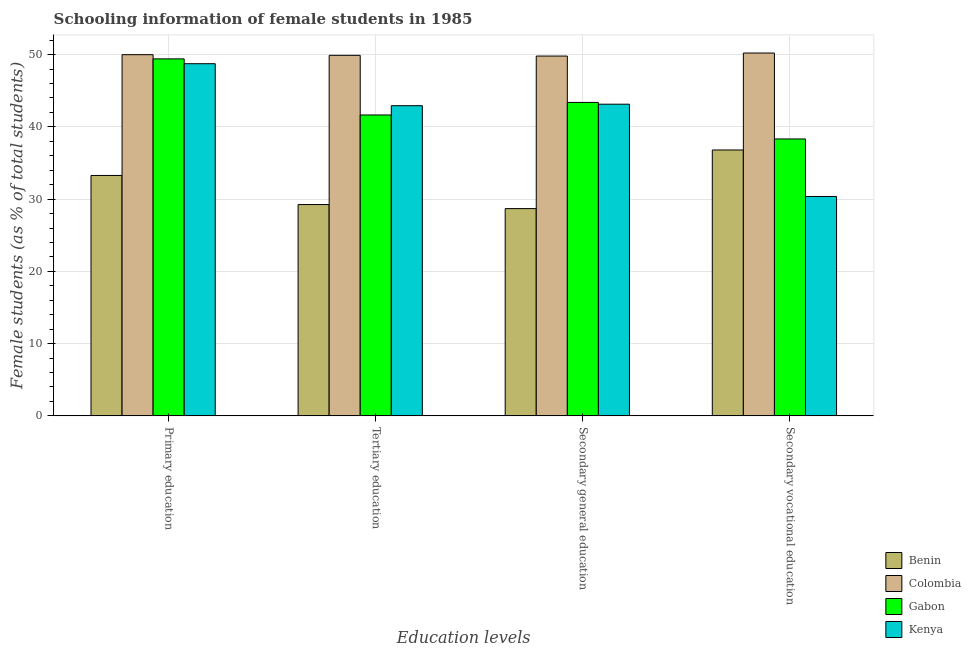How many different coloured bars are there?
Make the answer very short. 4. How many groups of bars are there?
Keep it short and to the point. 4. Are the number of bars per tick equal to the number of legend labels?
Give a very brief answer. Yes. How many bars are there on the 2nd tick from the left?
Keep it short and to the point. 4. What is the label of the 1st group of bars from the left?
Ensure brevity in your answer.  Primary education. What is the percentage of female students in primary education in Benin?
Your answer should be compact. 33.27. Across all countries, what is the maximum percentage of female students in secondary vocational education?
Provide a short and direct response. 50.22. Across all countries, what is the minimum percentage of female students in tertiary education?
Provide a succinct answer. 29.25. In which country was the percentage of female students in secondary education maximum?
Provide a short and direct response. Colombia. In which country was the percentage of female students in primary education minimum?
Provide a short and direct response. Benin. What is the total percentage of female students in primary education in the graph?
Provide a short and direct response. 181.41. What is the difference between the percentage of female students in secondary vocational education in Kenya and that in Benin?
Offer a very short reply. -6.44. What is the difference between the percentage of female students in secondary education in Gabon and the percentage of female students in tertiary education in Kenya?
Provide a short and direct response. 0.45. What is the average percentage of female students in secondary vocational education per country?
Your response must be concise. 38.93. What is the difference between the percentage of female students in tertiary education and percentage of female students in secondary vocational education in Kenya?
Provide a succinct answer. 12.56. In how many countries, is the percentage of female students in secondary education greater than 18 %?
Ensure brevity in your answer.  4. What is the ratio of the percentage of female students in primary education in Colombia to that in Gabon?
Your answer should be very brief. 1.01. Is the percentage of female students in secondary education in Gabon less than that in Colombia?
Your response must be concise. Yes. Is the difference between the percentage of female students in primary education in Kenya and Colombia greater than the difference between the percentage of female students in secondary education in Kenya and Colombia?
Your answer should be very brief. Yes. What is the difference between the highest and the second highest percentage of female students in primary education?
Make the answer very short. 0.58. What is the difference between the highest and the lowest percentage of female students in secondary education?
Make the answer very short. 21.11. In how many countries, is the percentage of female students in secondary education greater than the average percentage of female students in secondary education taken over all countries?
Your answer should be very brief. 3. Is the sum of the percentage of female students in tertiary education in Gabon and Kenya greater than the maximum percentage of female students in secondary education across all countries?
Your response must be concise. Yes. Is it the case that in every country, the sum of the percentage of female students in primary education and percentage of female students in secondary education is greater than the sum of percentage of female students in secondary vocational education and percentage of female students in tertiary education?
Provide a succinct answer. No. What does the 4th bar from the left in Secondary vocational education represents?
Make the answer very short. Kenya. What does the 1st bar from the right in Tertiary education represents?
Keep it short and to the point. Kenya. Is it the case that in every country, the sum of the percentage of female students in primary education and percentage of female students in tertiary education is greater than the percentage of female students in secondary education?
Your answer should be very brief. Yes. How many bars are there?
Offer a terse response. 16. Are all the bars in the graph horizontal?
Provide a short and direct response. No. How many countries are there in the graph?
Offer a terse response. 4. Does the graph contain grids?
Offer a terse response. Yes. How many legend labels are there?
Your response must be concise. 4. How are the legend labels stacked?
Provide a succinct answer. Vertical. What is the title of the graph?
Your response must be concise. Schooling information of female students in 1985. Does "Lao PDR" appear as one of the legend labels in the graph?
Your answer should be compact. No. What is the label or title of the X-axis?
Ensure brevity in your answer.  Education levels. What is the label or title of the Y-axis?
Provide a succinct answer. Female students (as % of total students). What is the Female students (as % of total students) of Benin in Primary education?
Your answer should be compact. 33.27. What is the Female students (as % of total students) of Colombia in Primary education?
Your answer should be compact. 49.99. What is the Female students (as % of total students) in Gabon in Primary education?
Provide a short and direct response. 49.41. What is the Female students (as % of total students) in Kenya in Primary education?
Your answer should be very brief. 48.74. What is the Female students (as % of total students) in Benin in Tertiary education?
Provide a succinct answer. 29.25. What is the Female students (as % of total students) of Colombia in Tertiary education?
Offer a terse response. 49.9. What is the Female students (as % of total students) in Gabon in Tertiary education?
Your answer should be compact. 41.64. What is the Female students (as % of total students) of Kenya in Tertiary education?
Your response must be concise. 42.93. What is the Female students (as % of total students) of Benin in Secondary general education?
Give a very brief answer. 28.69. What is the Female students (as % of total students) of Colombia in Secondary general education?
Offer a very short reply. 49.8. What is the Female students (as % of total students) of Gabon in Secondary general education?
Offer a very short reply. 43.38. What is the Female students (as % of total students) of Kenya in Secondary general education?
Offer a terse response. 43.14. What is the Female students (as % of total students) in Benin in Secondary vocational education?
Provide a short and direct response. 36.8. What is the Female students (as % of total students) in Colombia in Secondary vocational education?
Give a very brief answer. 50.22. What is the Female students (as % of total students) of Gabon in Secondary vocational education?
Give a very brief answer. 38.33. What is the Female students (as % of total students) in Kenya in Secondary vocational education?
Keep it short and to the point. 30.36. Across all Education levels, what is the maximum Female students (as % of total students) of Benin?
Your answer should be compact. 36.8. Across all Education levels, what is the maximum Female students (as % of total students) in Colombia?
Your answer should be very brief. 50.22. Across all Education levels, what is the maximum Female students (as % of total students) of Gabon?
Provide a short and direct response. 49.41. Across all Education levels, what is the maximum Female students (as % of total students) of Kenya?
Your answer should be compact. 48.74. Across all Education levels, what is the minimum Female students (as % of total students) in Benin?
Your answer should be compact. 28.69. Across all Education levels, what is the minimum Female students (as % of total students) of Colombia?
Your answer should be very brief. 49.8. Across all Education levels, what is the minimum Female students (as % of total students) of Gabon?
Your answer should be very brief. 38.33. Across all Education levels, what is the minimum Female students (as % of total students) of Kenya?
Make the answer very short. 30.36. What is the total Female students (as % of total students) of Benin in the graph?
Give a very brief answer. 128.01. What is the total Female students (as % of total students) of Colombia in the graph?
Offer a terse response. 199.91. What is the total Female students (as % of total students) of Gabon in the graph?
Your answer should be compact. 172.76. What is the total Female students (as % of total students) in Kenya in the graph?
Keep it short and to the point. 165.17. What is the difference between the Female students (as % of total students) in Benin in Primary education and that in Tertiary education?
Give a very brief answer. 4.03. What is the difference between the Female students (as % of total students) in Colombia in Primary education and that in Tertiary education?
Your response must be concise. 0.09. What is the difference between the Female students (as % of total students) of Gabon in Primary education and that in Tertiary education?
Offer a terse response. 7.76. What is the difference between the Female students (as % of total students) in Kenya in Primary education and that in Tertiary education?
Your response must be concise. 5.81. What is the difference between the Female students (as % of total students) in Benin in Primary education and that in Secondary general education?
Keep it short and to the point. 4.59. What is the difference between the Female students (as % of total students) in Colombia in Primary education and that in Secondary general education?
Offer a terse response. 0.19. What is the difference between the Female students (as % of total students) in Gabon in Primary education and that in Secondary general education?
Ensure brevity in your answer.  6.03. What is the difference between the Female students (as % of total students) in Kenya in Primary education and that in Secondary general education?
Your response must be concise. 5.6. What is the difference between the Female students (as % of total students) of Benin in Primary education and that in Secondary vocational education?
Offer a very short reply. -3.53. What is the difference between the Female students (as % of total students) of Colombia in Primary education and that in Secondary vocational education?
Give a very brief answer. -0.23. What is the difference between the Female students (as % of total students) of Gabon in Primary education and that in Secondary vocational education?
Your response must be concise. 11.08. What is the difference between the Female students (as % of total students) of Kenya in Primary education and that in Secondary vocational education?
Provide a succinct answer. 18.37. What is the difference between the Female students (as % of total students) in Benin in Tertiary education and that in Secondary general education?
Ensure brevity in your answer.  0.56. What is the difference between the Female students (as % of total students) of Colombia in Tertiary education and that in Secondary general education?
Provide a short and direct response. 0.1. What is the difference between the Female students (as % of total students) of Gabon in Tertiary education and that in Secondary general education?
Your response must be concise. -1.74. What is the difference between the Female students (as % of total students) in Kenya in Tertiary education and that in Secondary general education?
Ensure brevity in your answer.  -0.21. What is the difference between the Female students (as % of total students) of Benin in Tertiary education and that in Secondary vocational education?
Provide a succinct answer. -7.55. What is the difference between the Female students (as % of total students) of Colombia in Tertiary education and that in Secondary vocational education?
Provide a succinct answer. -0.32. What is the difference between the Female students (as % of total students) of Gabon in Tertiary education and that in Secondary vocational education?
Offer a terse response. 3.32. What is the difference between the Female students (as % of total students) of Kenya in Tertiary education and that in Secondary vocational education?
Your answer should be compact. 12.56. What is the difference between the Female students (as % of total students) of Benin in Secondary general education and that in Secondary vocational education?
Keep it short and to the point. -8.11. What is the difference between the Female students (as % of total students) of Colombia in Secondary general education and that in Secondary vocational education?
Give a very brief answer. -0.42. What is the difference between the Female students (as % of total students) in Gabon in Secondary general education and that in Secondary vocational education?
Give a very brief answer. 5.06. What is the difference between the Female students (as % of total students) of Kenya in Secondary general education and that in Secondary vocational education?
Ensure brevity in your answer.  12.77. What is the difference between the Female students (as % of total students) of Benin in Primary education and the Female students (as % of total students) of Colombia in Tertiary education?
Keep it short and to the point. -16.63. What is the difference between the Female students (as % of total students) in Benin in Primary education and the Female students (as % of total students) in Gabon in Tertiary education?
Your response must be concise. -8.37. What is the difference between the Female students (as % of total students) in Benin in Primary education and the Female students (as % of total students) in Kenya in Tertiary education?
Keep it short and to the point. -9.66. What is the difference between the Female students (as % of total students) in Colombia in Primary education and the Female students (as % of total students) in Gabon in Tertiary education?
Your answer should be compact. 8.35. What is the difference between the Female students (as % of total students) in Colombia in Primary education and the Female students (as % of total students) in Kenya in Tertiary education?
Provide a succinct answer. 7.06. What is the difference between the Female students (as % of total students) of Gabon in Primary education and the Female students (as % of total students) of Kenya in Tertiary education?
Give a very brief answer. 6.48. What is the difference between the Female students (as % of total students) in Benin in Primary education and the Female students (as % of total students) in Colombia in Secondary general education?
Your answer should be compact. -16.53. What is the difference between the Female students (as % of total students) in Benin in Primary education and the Female students (as % of total students) in Gabon in Secondary general education?
Keep it short and to the point. -10.11. What is the difference between the Female students (as % of total students) of Benin in Primary education and the Female students (as % of total students) of Kenya in Secondary general education?
Ensure brevity in your answer.  -9.86. What is the difference between the Female students (as % of total students) in Colombia in Primary education and the Female students (as % of total students) in Gabon in Secondary general education?
Provide a succinct answer. 6.61. What is the difference between the Female students (as % of total students) of Colombia in Primary education and the Female students (as % of total students) of Kenya in Secondary general education?
Offer a very short reply. 6.85. What is the difference between the Female students (as % of total students) in Gabon in Primary education and the Female students (as % of total students) in Kenya in Secondary general education?
Provide a succinct answer. 6.27. What is the difference between the Female students (as % of total students) of Benin in Primary education and the Female students (as % of total students) of Colombia in Secondary vocational education?
Make the answer very short. -16.95. What is the difference between the Female students (as % of total students) in Benin in Primary education and the Female students (as % of total students) in Gabon in Secondary vocational education?
Offer a very short reply. -5.05. What is the difference between the Female students (as % of total students) in Benin in Primary education and the Female students (as % of total students) in Kenya in Secondary vocational education?
Keep it short and to the point. 2.91. What is the difference between the Female students (as % of total students) in Colombia in Primary education and the Female students (as % of total students) in Gabon in Secondary vocational education?
Your answer should be compact. 11.66. What is the difference between the Female students (as % of total students) in Colombia in Primary education and the Female students (as % of total students) in Kenya in Secondary vocational education?
Keep it short and to the point. 19.62. What is the difference between the Female students (as % of total students) in Gabon in Primary education and the Female students (as % of total students) in Kenya in Secondary vocational education?
Give a very brief answer. 19.04. What is the difference between the Female students (as % of total students) of Benin in Tertiary education and the Female students (as % of total students) of Colombia in Secondary general education?
Ensure brevity in your answer.  -20.55. What is the difference between the Female students (as % of total students) of Benin in Tertiary education and the Female students (as % of total students) of Gabon in Secondary general education?
Keep it short and to the point. -14.14. What is the difference between the Female students (as % of total students) in Benin in Tertiary education and the Female students (as % of total students) in Kenya in Secondary general education?
Provide a short and direct response. -13.89. What is the difference between the Female students (as % of total students) of Colombia in Tertiary education and the Female students (as % of total students) of Gabon in Secondary general education?
Keep it short and to the point. 6.52. What is the difference between the Female students (as % of total students) in Colombia in Tertiary education and the Female students (as % of total students) in Kenya in Secondary general education?
Offer a very short reply. 6.76. What is the difference between the Female students (as % of total students) of Gabon in Tertiary education and the Female students (as % of total students) of Kenya in Secondary general education?
Your answer should be compact. -1.49. What is the difference between the Female students (as % of total students) in Benin in Tertiary education and the Female students (as % of total students) in Colombia in Secondary vocational education?
Keep it short and to the point. -20.97. What is the difference between the Female students (as % of total students) of Benin in Tertiary education and the Female students (as % of total students) of Gabon in Secondary vocational education?
Ensure brevity in your answer.  -9.08. What is the difference between the Female students (as % of total students) in Benin in Tertiary education and the Female students (as % of total students) in Kenya in Secondary vocational education?
Provide a succinct answer. -1.12. What is the difference between the Female students (as % of total students) of Colombia in Tertiary education and the Female students (as % of total students) of Gabon in Secondary vocational education?
Give a very brief answer. 11.57. What is the difference between the Female students (as % of total students) of Colombia in Tertiary education and the Female students (as % of total students) of Kenya in Secondary vocational education?
Provide a short and direct response. 19.54. What is the difference between the Female students (as % of total students) of Gabon in Tertiary education and the Female students (as % of total students) of Kenya in Secondary vocational education?
Ensure brevity in your answer.  11.28. What is the difference between the Female students (as % of total students) in Benin in Secondary general education and the Female students (as % of total students) in Colombia in Secondary vocational education?
Keep it short and to the point. -21.53. What is the difference between the Female students (as % of total students) of Benin in Secondary general education and the Female students (as % of total students) of Gabon in Secondary vocational education?
Provide a short and direct response. -9.64. What is the difference between the Female students (as % of total students) of Benin in Secondary general education and the Female students (as % of total students) of Kenya in Secondary vocational education?
Make the answer very short. -1.68. What is the difference between the Female students (as % of total students) of Colombia in Secondary general education and the Female students (as % of total students) of Gabon in Secondary vocational education?
Make the answer very short. 11.47. What is the difference between the Female students (as % of total students) in Colombia in Secondary general education and the Female students (as % of total students) in Kenya in Secondary vocational education?
Offer a very short reply. 19.43. What is the difference between the Female students (as % of total students) of Gabon in Secondary general education and the Female students (as % of total students) of Kenya in Secondary vocational education?
Offer a very short reply. 13.02. What is the average Female students (as % of total students) in Benin per Education levels?
Offer a very short reply. 32. What is the average Female students (as % of total students) in Colombia per Education levels?
Offer a very short reply. 49.98. What is the average Female students (as % of total students) of Gabon per Education levels?
Provide a short and direct response. 43.19. What is the average Female students (as % of total students) in Kenya per Education levels?
Your response must be concise. 41.29. What is the difference between the Female students (as % of total students) of Benin and Female students (as % of total students) of Colombia in Primary education?
Ensure brevity in your answer.  -16.72. What is the difference between the Female students (as % of total students) in Benin and Female students (as % of total students) in Gabon in Primary education?
Keep it short and to the point. -16.14. What is the difference between the Female students (as % of total students) of Benin and Female students (as % of total students) of Kenya in Primary education?
Offer a very short reply. -15.47. What is the difference between the Female students (as % of total students) of Colombia and Female students (as % of total students) of Gabon in Primary education?
Keep it short and to the point. 0.58. What is the difference between the Female students (as % of total students) of Colombia and Female students (as % of total students) of Kenya in Primary education?
Keep it short and to the point. 1.25. What is the difference between the Female students (as % of total students) in Gabon and Female students (as % of total students) in Kenya in Primary education?
Give a very brief answer. 0.67. What is the difference between the Female students (as % of total students) in Benin and Female students (as % of total students) in Colombia in Tertiary education?
Keep it short and to the point. -20.65. What is the difference between the Female students (as % of total students) of Benin and Female students (as % of total students) of Gabon in Tertiary education?
Provide a succinct answer. -12.4. What is the difference between the Female students (as % of total students) of Benin and Female students (as % of total students) of Kenya in Tertiary education?
Your answer should be very brief. -13.68. What is the difference between the Female students (as % of total students) in Colombia and Female students (as % of total students) in Gabon in Tertiary education?
Make the answer very short. 8.26. What is the difference between the Female students (as % of total students) in Colombia and Female students (as % of total students) in Kenya in Tertiary education?
Offer a very short reply. 6.97. What is the difference between the Female students (as % of total students) of Gabon and Female students (as % of total students) of Kenya in Tertiary education?
Your response must be concise. -1.29. What is the difference between the Female students (as % of total students) in Benin and Female students (as % of total students) in Colombia in Secondary general education?
Offer a very short reply. -21.11. What is the difference between the Female students (as % of total students) in Benin and Female students (as % of total students) in Gabon in Secondary general education?
Make the answer very short. -14.7. What is the difference between the Female students (as % of total students) of Benin and Female students (as % of total students) of Kenya in Secondary general education?
Give a very brief answer. -14.45. What is the difference between the Female students (as % of total students) in Colombia and Female students (as % of total students) in Gabon in Secondary general education?
Your response must be concise. 6.42. What is the difference between the Female students (as % of total students) of Colombia and Female students (as % of total students) of Kenya in Secondary general education?
Give a very brief answer. 6.66. What is the difference between the Female students (as % of total students) of Gabon and Female students (as % of total students) of Kenya in Secondary general education?
Offer a terse response. 0.25. What is the difference between the Female students (as % of total students) in Benin and Female students (as % of total students) in Colombia in Secondary vocational education?
Provide a short and direct response. -13.42. What is the difference between the Female students (as % of total students) of Benin and Female students (as % of total students) of Gabon in Secondary vocational education?
Ensure brevity in your answer.  -1.52. What is the difference between the Female students (as % of total students) of Benin and Female students (as % of total students) of Kenya in Secondary vocational education?
Give a very brief answer. 6.44. What is the difference between the Female students (as % of total students) in Colombia and Female students (as % of total students) in Gabon in Secondary vocational education?
Make the answer very short. 11.89. What is the difference between the Female students (as % of total students) in Colombia and Female students (as % of total students) in Kenya in Secondary vocational education?
Your answer should be compact. 19.85. What is the difference between the Female students (as % of total students) in Gabon and Female students (as % of total students) in Kenya in Secondary vocational education?
Your response must be concise. 7.96. What is the ratio of the Female students (as % of total students) of Benin in Primary education to that in Tertiary education?
Your answer should be very brief. 1.14. What is the ratio of the Female students (as % of total students) in Gabon in Primary education to that in Tertiary education?
Offer a very short reply. 1.19. What is the ratio of the Female students (as % of total students) in Kenya in Primary education to that in Tertiary education?
Your answer should be very brief. 1.14. What is the ratio of the Female students (as % of total students) in Benin in Primary education to that in Secondary general education?
Your answer should be compact. 1.16. What is the ratio of the Female students (as % of total students) in Colombia in Primary education to that in Secondary general education?
Your response must be concise. 1. What is the ratio of the Female students (as % of total students) in Gabon in Primary education to that in Secondary general education?
Provide a succinct answer. 1.14. What is the ratio of the Female students (as % of total students) in Kenya in Primary education to that in Secondary general education?
Provide a succinct answer. 1.13. What is the ratio of the Female students (as % of total students) of Benin in Primary education to that in Secondary vocational education?
Offer a very short reply. 0.9. What is the ratio of the Female students (as % of total students) in Gabon in Primary education to that in Secondary vocational education?
Offer a terse response. 1.29. What is the ratio of the Female students (as % of total students) in Kenya in Primary education to that in Secondary vocational education?
Provide a short and direct response. 1.61. What is the ratio of the Female students (as % of total students) in Benin in Tertiary education to that in Secondary general education?
Your answer should be compact. 1.02. What is the ratio of the Female students (as % of total students) in Gabon in Tertiary education to that in Secondary general education?
Provide a succinct answer. 0.96. What is the ratio of the Female students (as % of total students) of Kenya in Tertiary education to that in Secondary general education?
Offer a very short reply. 1. What is the ratio of the Female students (as % of total students) in Benin in Tertiary education to that in Secondary vocational education?
Provide a short and direct response. 0.79. What is the ratio of the Female students (as % of total students) in Gabon in Tertiary education to that in Secondary vocational education?
Make the answer very short. 1.09. What is the ratio of the Female students (as % of total students) in Kenya in Tertiary education to that in Secondary vocational education?
Your response must be concise. 1.41. What is the ratio of the Female students (as % of total students) of Benin in Secondary general education to that in Secondary vocational education?
Offer a very short reply. 0.78. What is the ratio of the Female students (as % of total students) of Gabon in Secondary general education to that in Secondary vocational education?
Provide a short and direct response. 1.13. What is the ratio of the Female students (as % of total students) in Kenya in Secondary general education to that in Secondary vocational education?
Provide a succinct answer. 1.42. What is the difference between the highest and the second highest Female students (as % of total students) of Benin?
Offer a terse response. 3.53. What is the difference between the highest and the second highest Female students (as % of total students) in Colombia?
Provide a short and direct response. 0.23. What is the difference between the highest and the second highest Female students (as % of total students) of Gabon?
Keep it short and to the point. 6.03. What is the difference between the highest and the second highest Female students (as % of total students) in Kenya?
Provide a short and direct response. 5.6. What is the difference between the highest and the lowest Female students (as % of total students) of Benin?
Ensure brevity in your answer.  8.11. What is the difference between the highest and the lowest Female students (as % of total students) of Colombia?
Ensure brevity in your answer.  0.42. What is the difference between the highest and the lowest Female students (as % of total students) of Gabon?
Your response must be concise. 11.08. What is the difference between the highest and the lowest Female students (as % of total students) of Kenya?
Your answer should be compact. 18.37. 